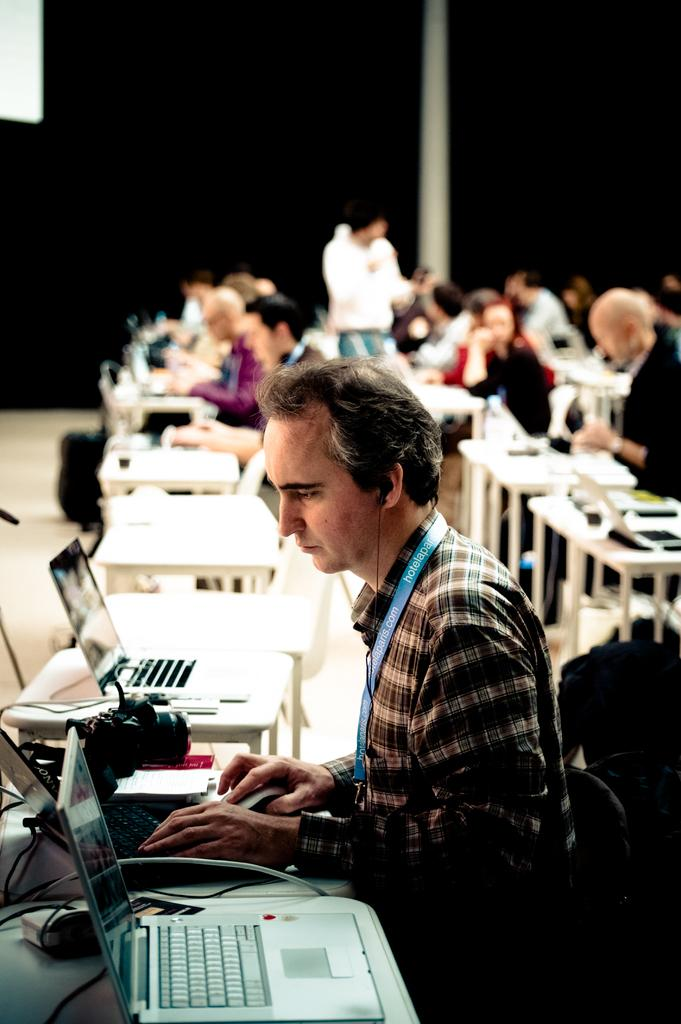What are the persons in the image doing? The persons in the image are sitting. Where are the persons sitting in relation to the tables? The persons are sitting in front of tables. What electronic devices can be seen in the image? There are laptops in the bottom left of the image. Can you describe the background of the image? The background of the image is blurred. Are there any ants crawling on the laptops in the image? There is no indication of ants in the image; the focus is on the persons sitting and the laptops. 